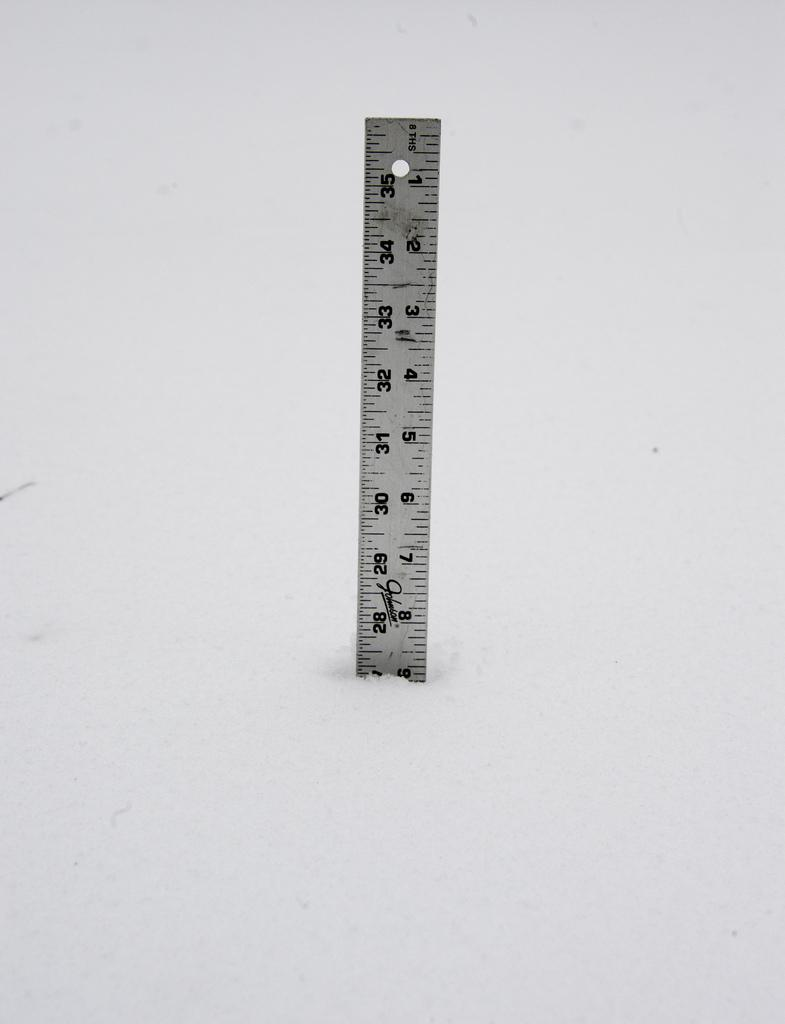<image>
Provide a brief description of the given image. The ruler shown has been broken at 9 inches. 